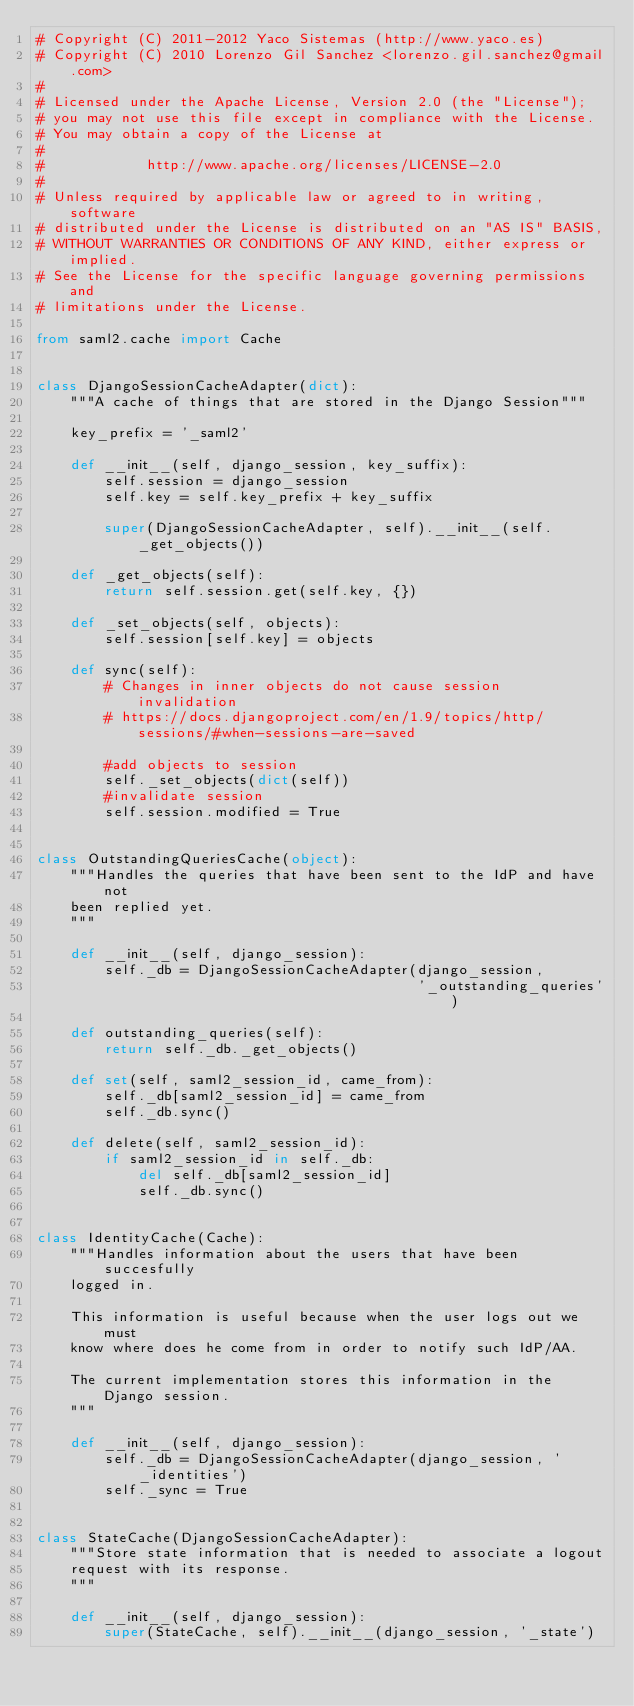Convert code to text. <code><loc_0><loc_0><loc_500><loc_500><_Python_># Copyright (C) 2011-2012 Yaco Sistemas (http://www.yaco.es)
# Copyright (C) 2010 Lorenzo Gil Sanchez <lorenzo.gil.sanchez@gmail.com>
#
# Licensed under the Apache License, Version 2.0 (the "License");
# you may not use this file except in compliance with the License.
# You may obtain a copy of the License at
#
#            http://www.apache.org/licenses/LICENSE-2.0
#
# Unless required by applicable law or agreed to in writing, software
# distributed under the License is distributed on an "AS IS" BASIS,
# WITHOUT WARRANTIES OR CONDITIONS OF ANY KIND, either express or implied.
# See the License for the specific language governing permissions and
# limitations under the License.

from saml2.cache import Cache


class DjangoSessionCacheAdapter(dict):
    """A cache of things that are stored in the Django Session"""

    key_prefix = '_saml2'

    def __init__(self, django_session, key_suffix):
        self.session = django_session
        self.key = self.key_prefix + key_suffix

        super(DjangoSessionCacheAdapter, self).__init__(self._get_objects())

    def _get_objects(self):
        return self.session.get(self.key, {})

    def _set_objects(self, objects):
        self.session[self.key] = objects

    def sync(self):
        # Changes in inner objects do not cause session invalidation
        # https://docs.djangoproject.com/en/1.9/topics/http/sessions/#when-sessions-are-saved

        #add objects to session
        self._set_objects(dict(self))
        #invalidate session
        self.session.modified = True


class OutstandingQueriesCache(object):
    """Handles the queries that have been sent to the IdP and have not
    been replied yet.
    """

    def __init__(self, django_session):
        self._db = DjangoSessionCacheAdapter(django_session,
                                             '_outstanding_queries')

    def outstanding_queries(self):
        return self._db._get_objects()

    def set(self, saml2_session_id, came_from):
        self._db[saml2_session_id] = came_from
        self._db.sync()

    def delete(self, saml2_session_id):
        if saml2_session_id in self._db:
            del self._db[saml2_session_id]
            self._db.sync()


class IdentityCache(Cache):
    """Handles information about the users that have been succesfully
    logged in.

    This information is useful because when the user logs out we must
    know where does he come from in order to notify such IdP/AA.

    The current implementation stores this information in the Django session.
    """

    def __init__(self, django_session):
        self._db = DjangoSessionCacheAdapter(django_session, '_identities')
        self._sync = True


class StateCache(DjangoSessionCacheAdapter):
    """Store state information that is needed to associate a logout
    request with its response.
    """

    def __init__(self, django_session):
        super(StateCache, self).__init__(django_session, '_state')
</code> 